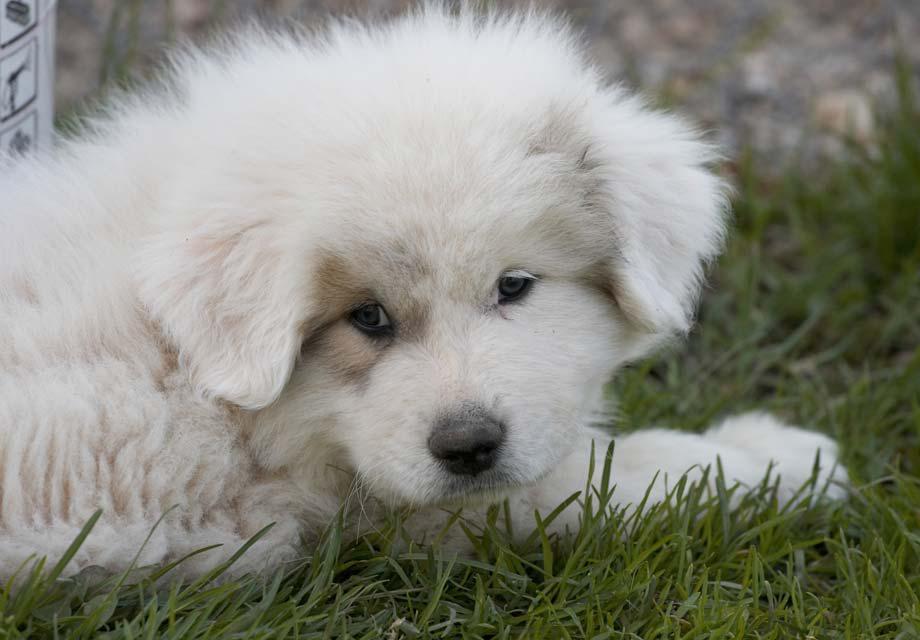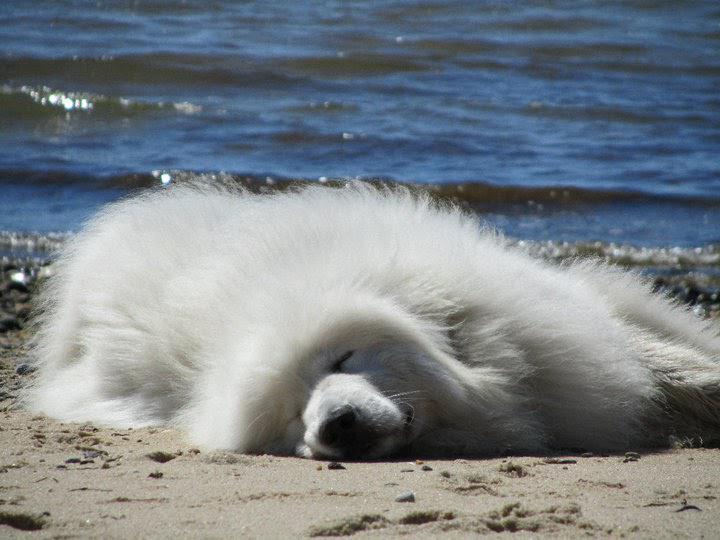The first image is the image on the left, the second image is the image on the right. For the images shown, is this caption "The dog int he image on the right is standing in a grassy area." true? Answer yes or no. No. The first image is the image on the left, the second image is the image on the right. Assess this claim about the two images: "A white animal is sleeping by water in one of its states of matter.". Correct or not? Answer yes or no. Yes. 